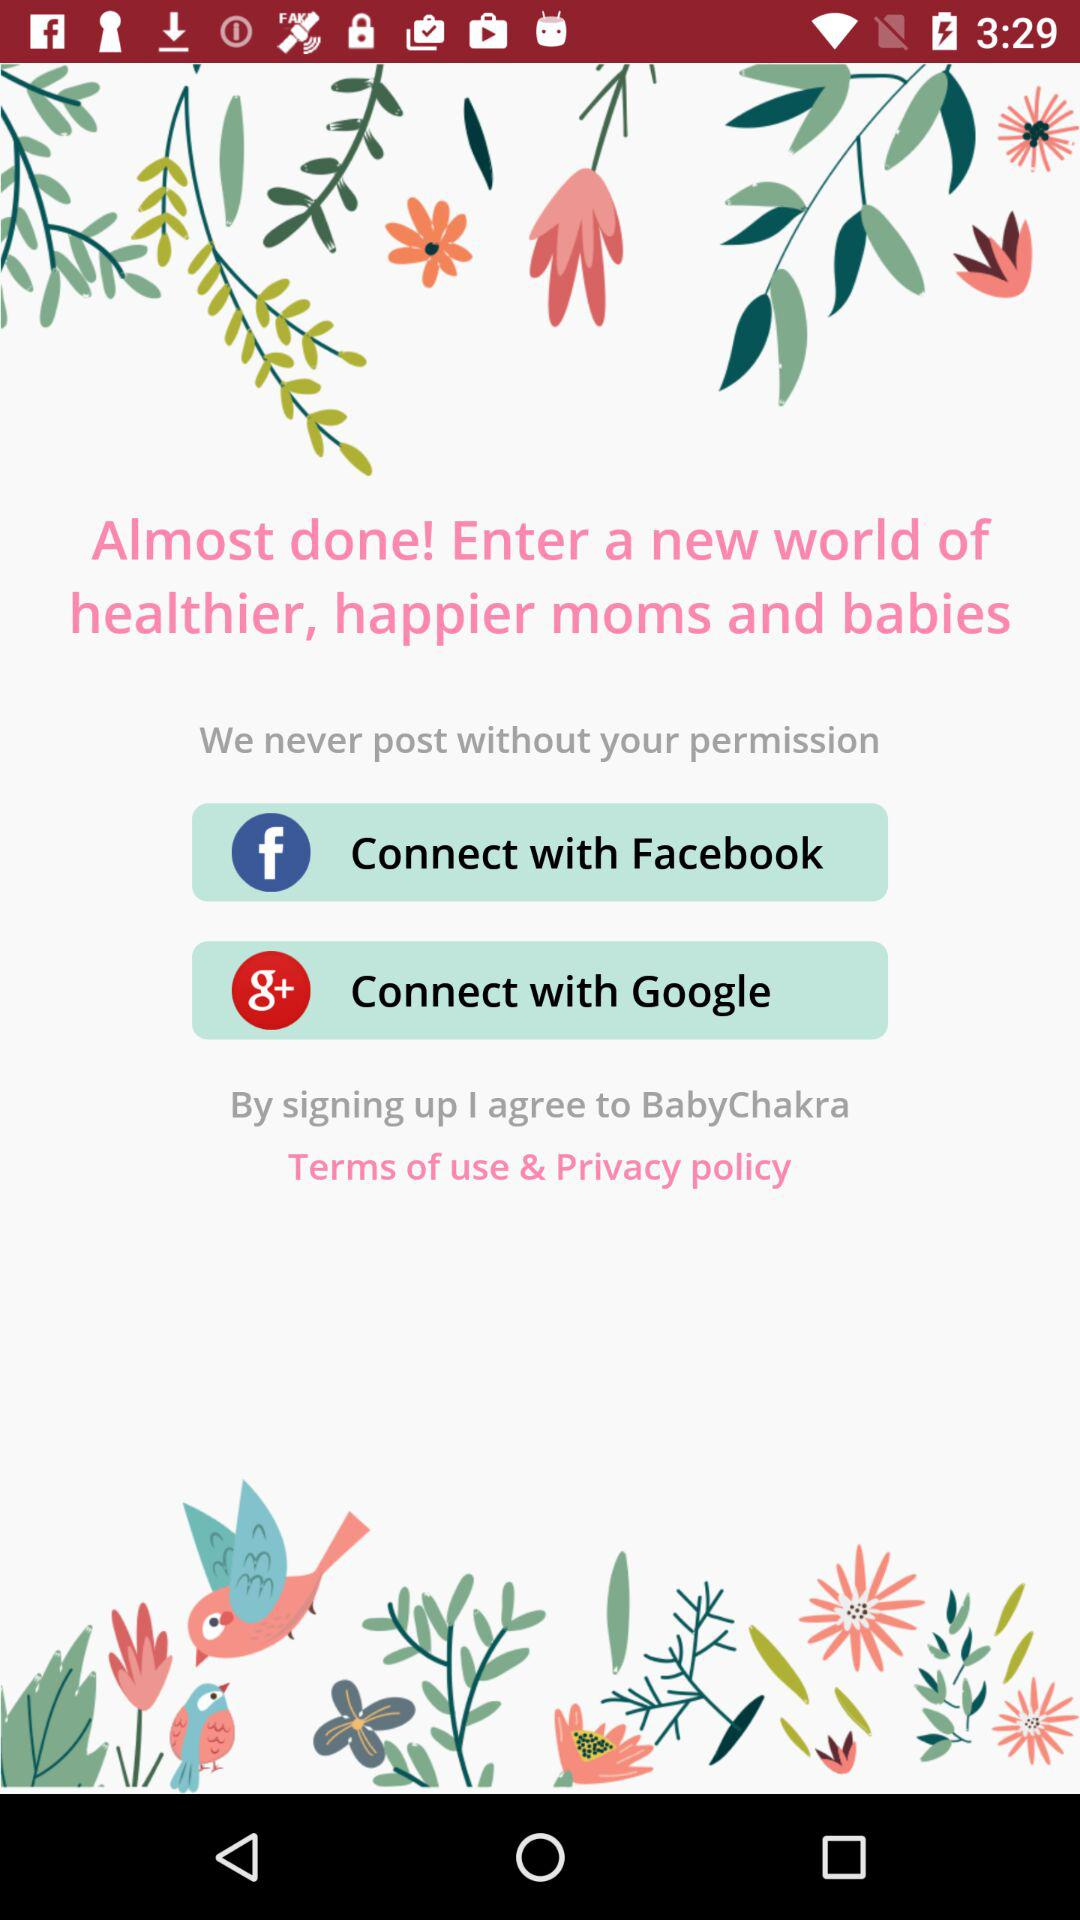Which applications are used to connect? Connect with Facebook and Connect with Google applications are used to connect. 